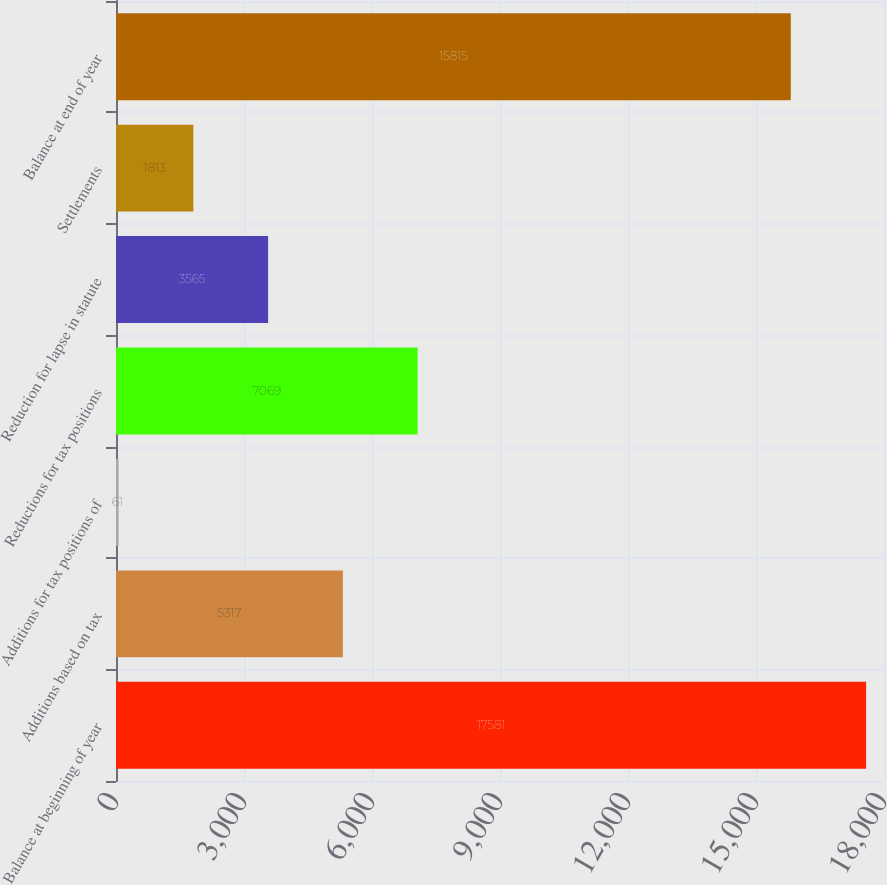Convert chart to OTSL. <chart><loc_0><loc_0><loc_500><loc_500><bar_chart><fcel>Balance at beginning of year<fcel>Additions based on tax<fcel>Additions for tax positions of<fcel>Reductions for tax positions<fcel>Reduction for lapse in statute<fcel>Settlements<fcel>Balance at end of year<nl><fcel>17581<fcel>5317<fcel>61<fcel>7069<fcel>3565<fcel>1813<fcel>15815<nl></chart> 